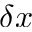Convert formula to latex. <formula><loc_0><loc_0><loc_500><loc_500>\delta x</formula> 